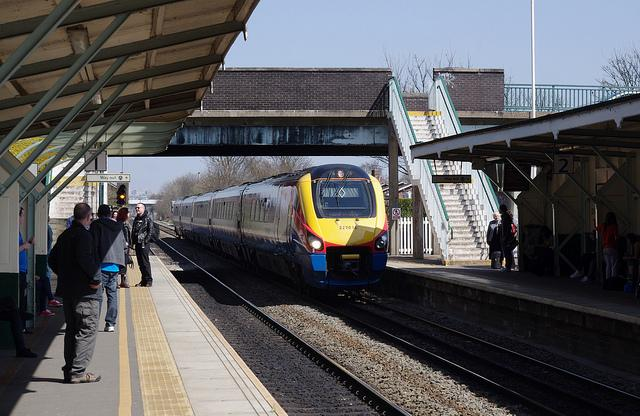Which platform services the train arriving now? Please explain your reasoning. right. The train is on the right tracks so it would be using the right-side platform. 